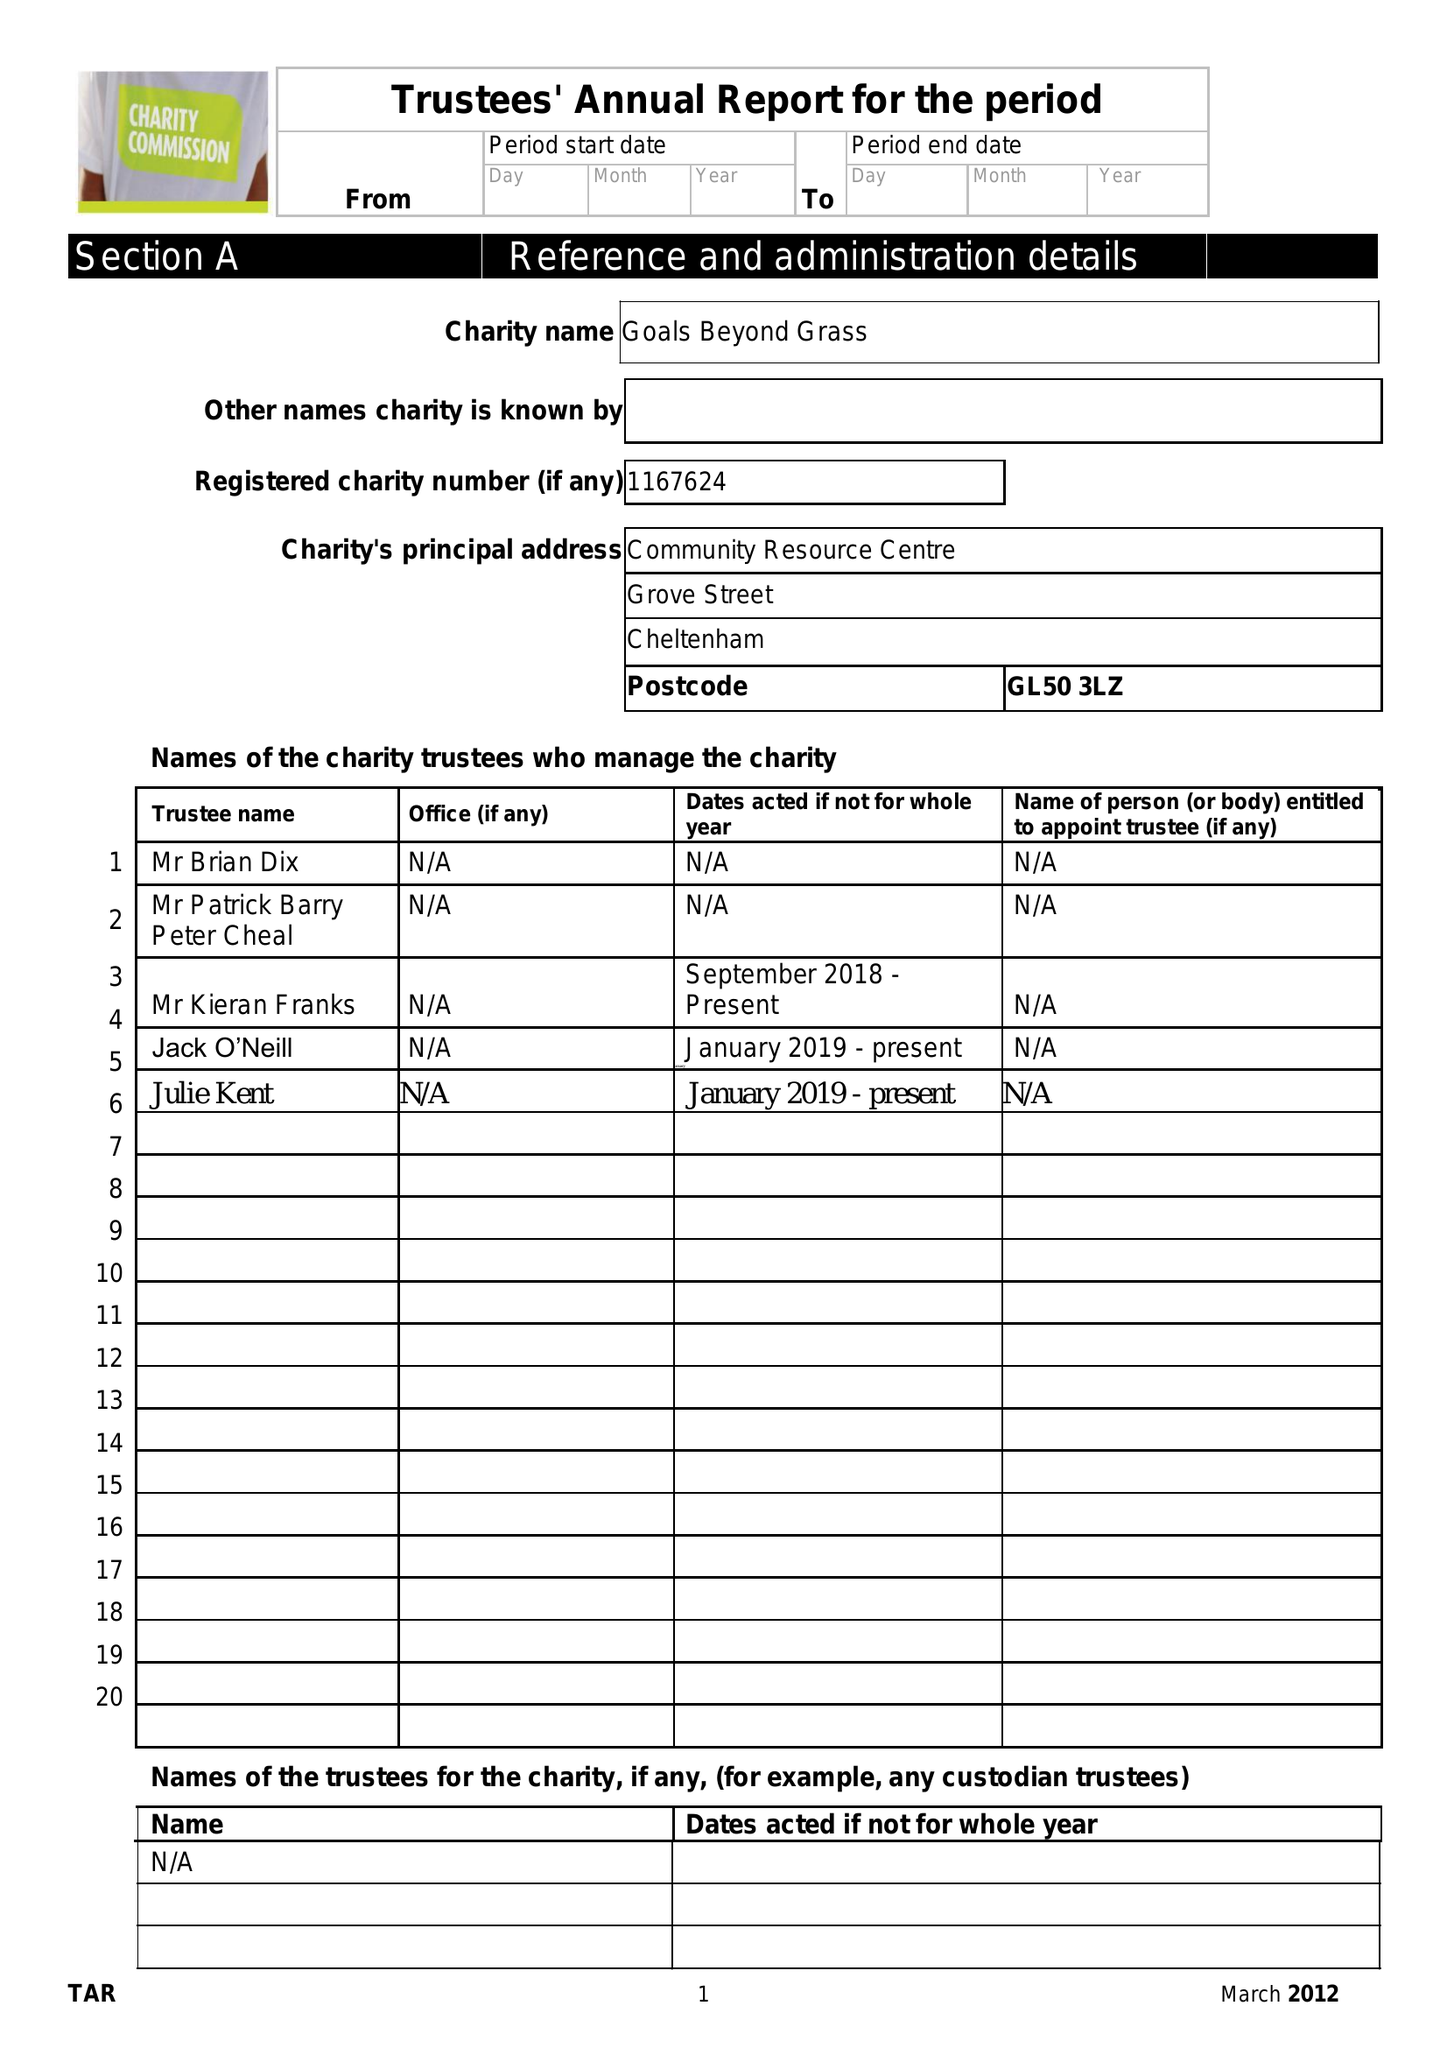What is the value for the address__post_town?
Answer the question using a single word or phrase. GLOUCESTER 